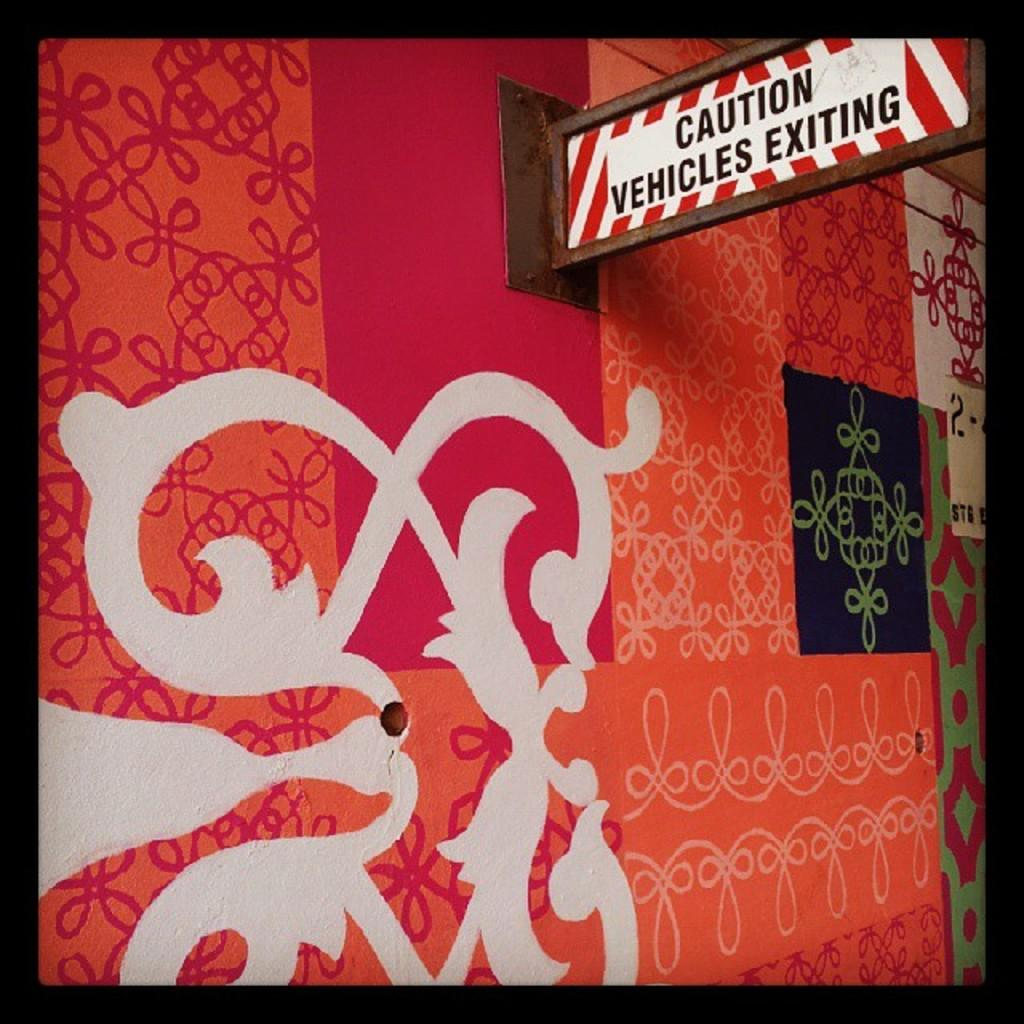Provide a one-sentence caption for the provided image. A colorful wall with many designs including a sign that reads: Caution Vehicles Exiting. 